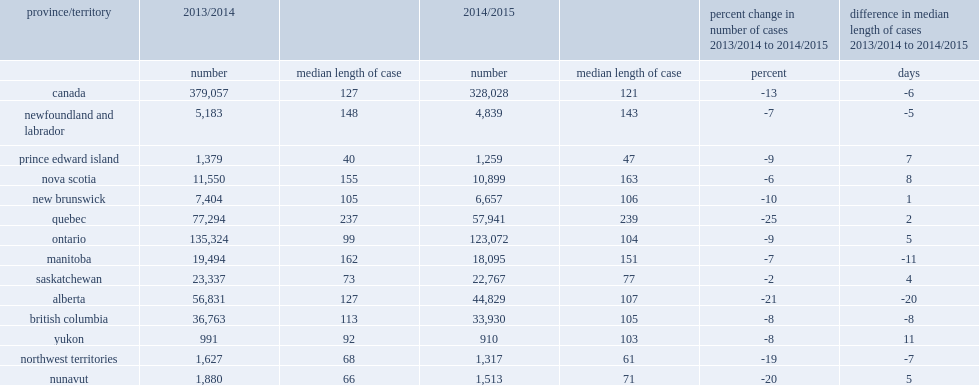What is the number have completed cases decreased in quebec from 2013/2014 to 2014/2015? 19353. How many percentage points did the number of completed cases decrease in quebec from 2013/2014 to 2014/2015? 25. How many percentage points did the number of completed cases change in ontario from 2013/2014 to 2014/2015? -9.0. How many percentage points did the number of completed cases change in alberta from 2013/2014 to 2014/2015? -21.0. 